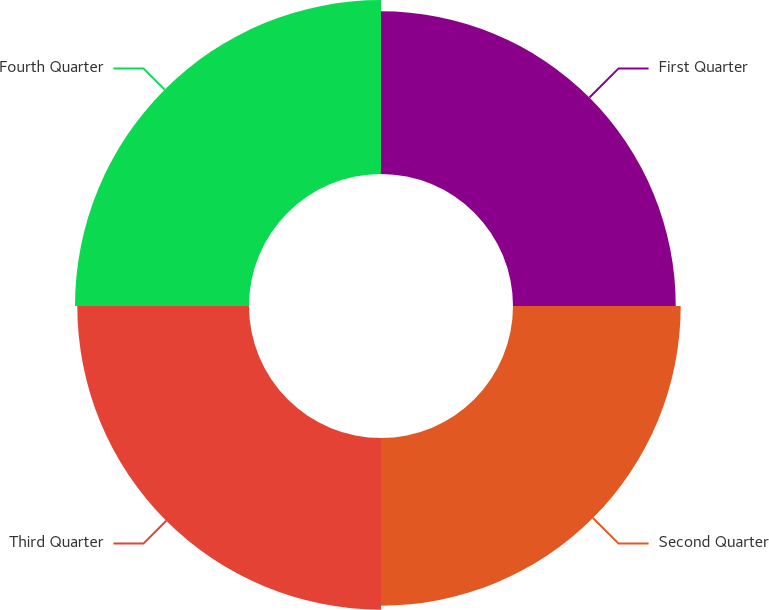<chart> <loc_0><loc_0><loc_500><loc_500><pie_chart><fcel>First Quarter<fcel>Second Quarter<fcel>Third Quarter<fcel>Fourth Quarter<nl><fcel>24.07%<fcel>24.8%<fcel>25.39%<fcel>25.73%<nl></chart> 